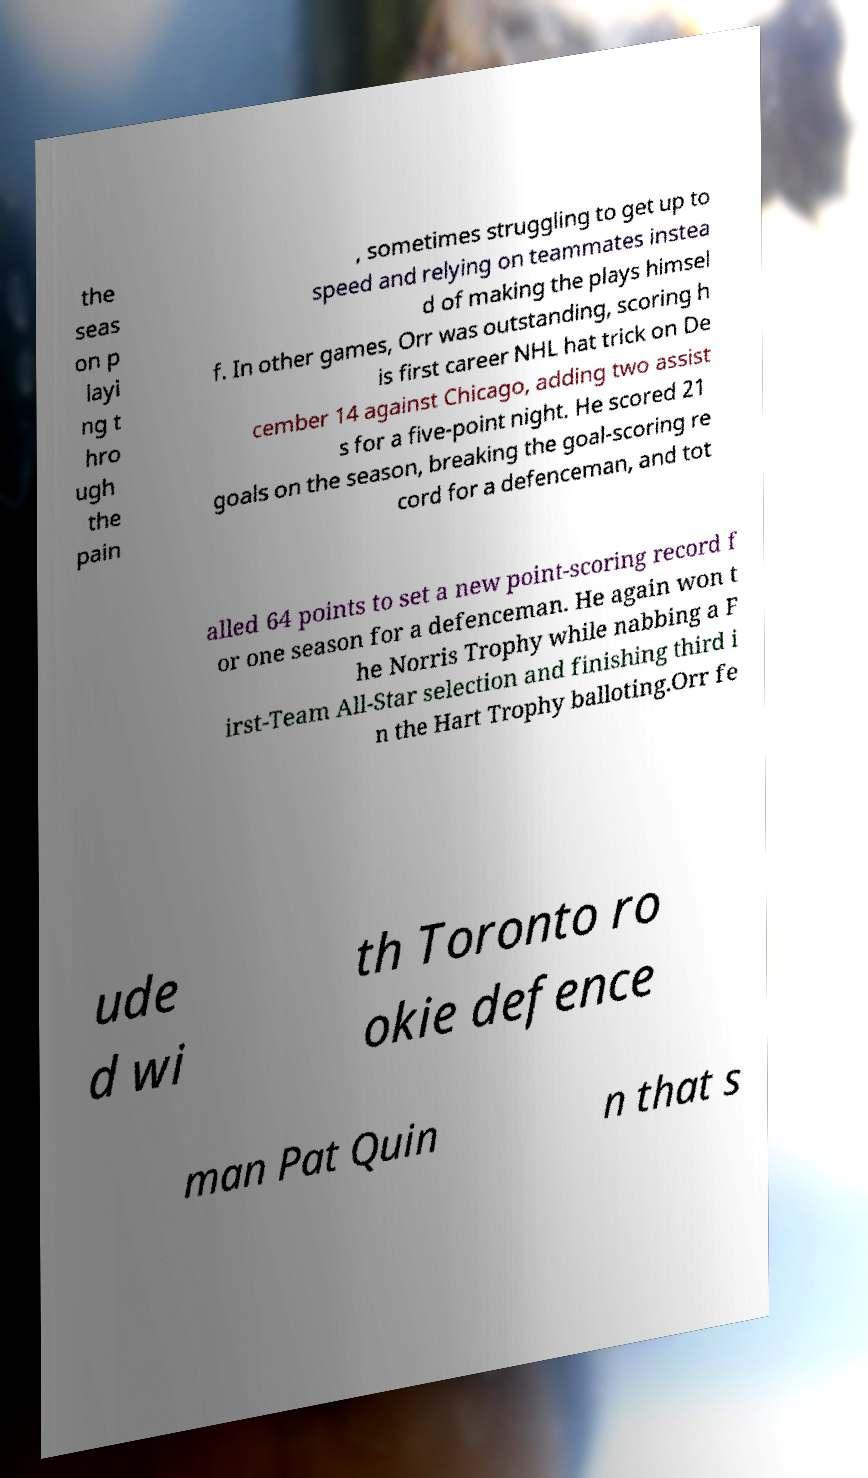I need the written content from this picture converted into text. Can you do that? the seas on p layi ng t hro ugh the pain , sometimes struggling to get up to speed and relying on teammates instea d of making the plays himsel f. In other games, Orr was outstanding, scoring h is first career NHL hat trick on De cember 14 against Chicago, adding two assist s for a five-point night. He scored 21 goals on the season, breaking the goal-scoring re cord for a defenceman, and tot alled 64 points to set a new point-scoring record f or one season for a defenceman. He again won t he Norris Trophy while nabbing a F irst-Team All-Star selection and finishing third i n the Hart Trophy balloting.Orr fe ude d wi th Toronto ro okie defence man Pat Quin n that s 